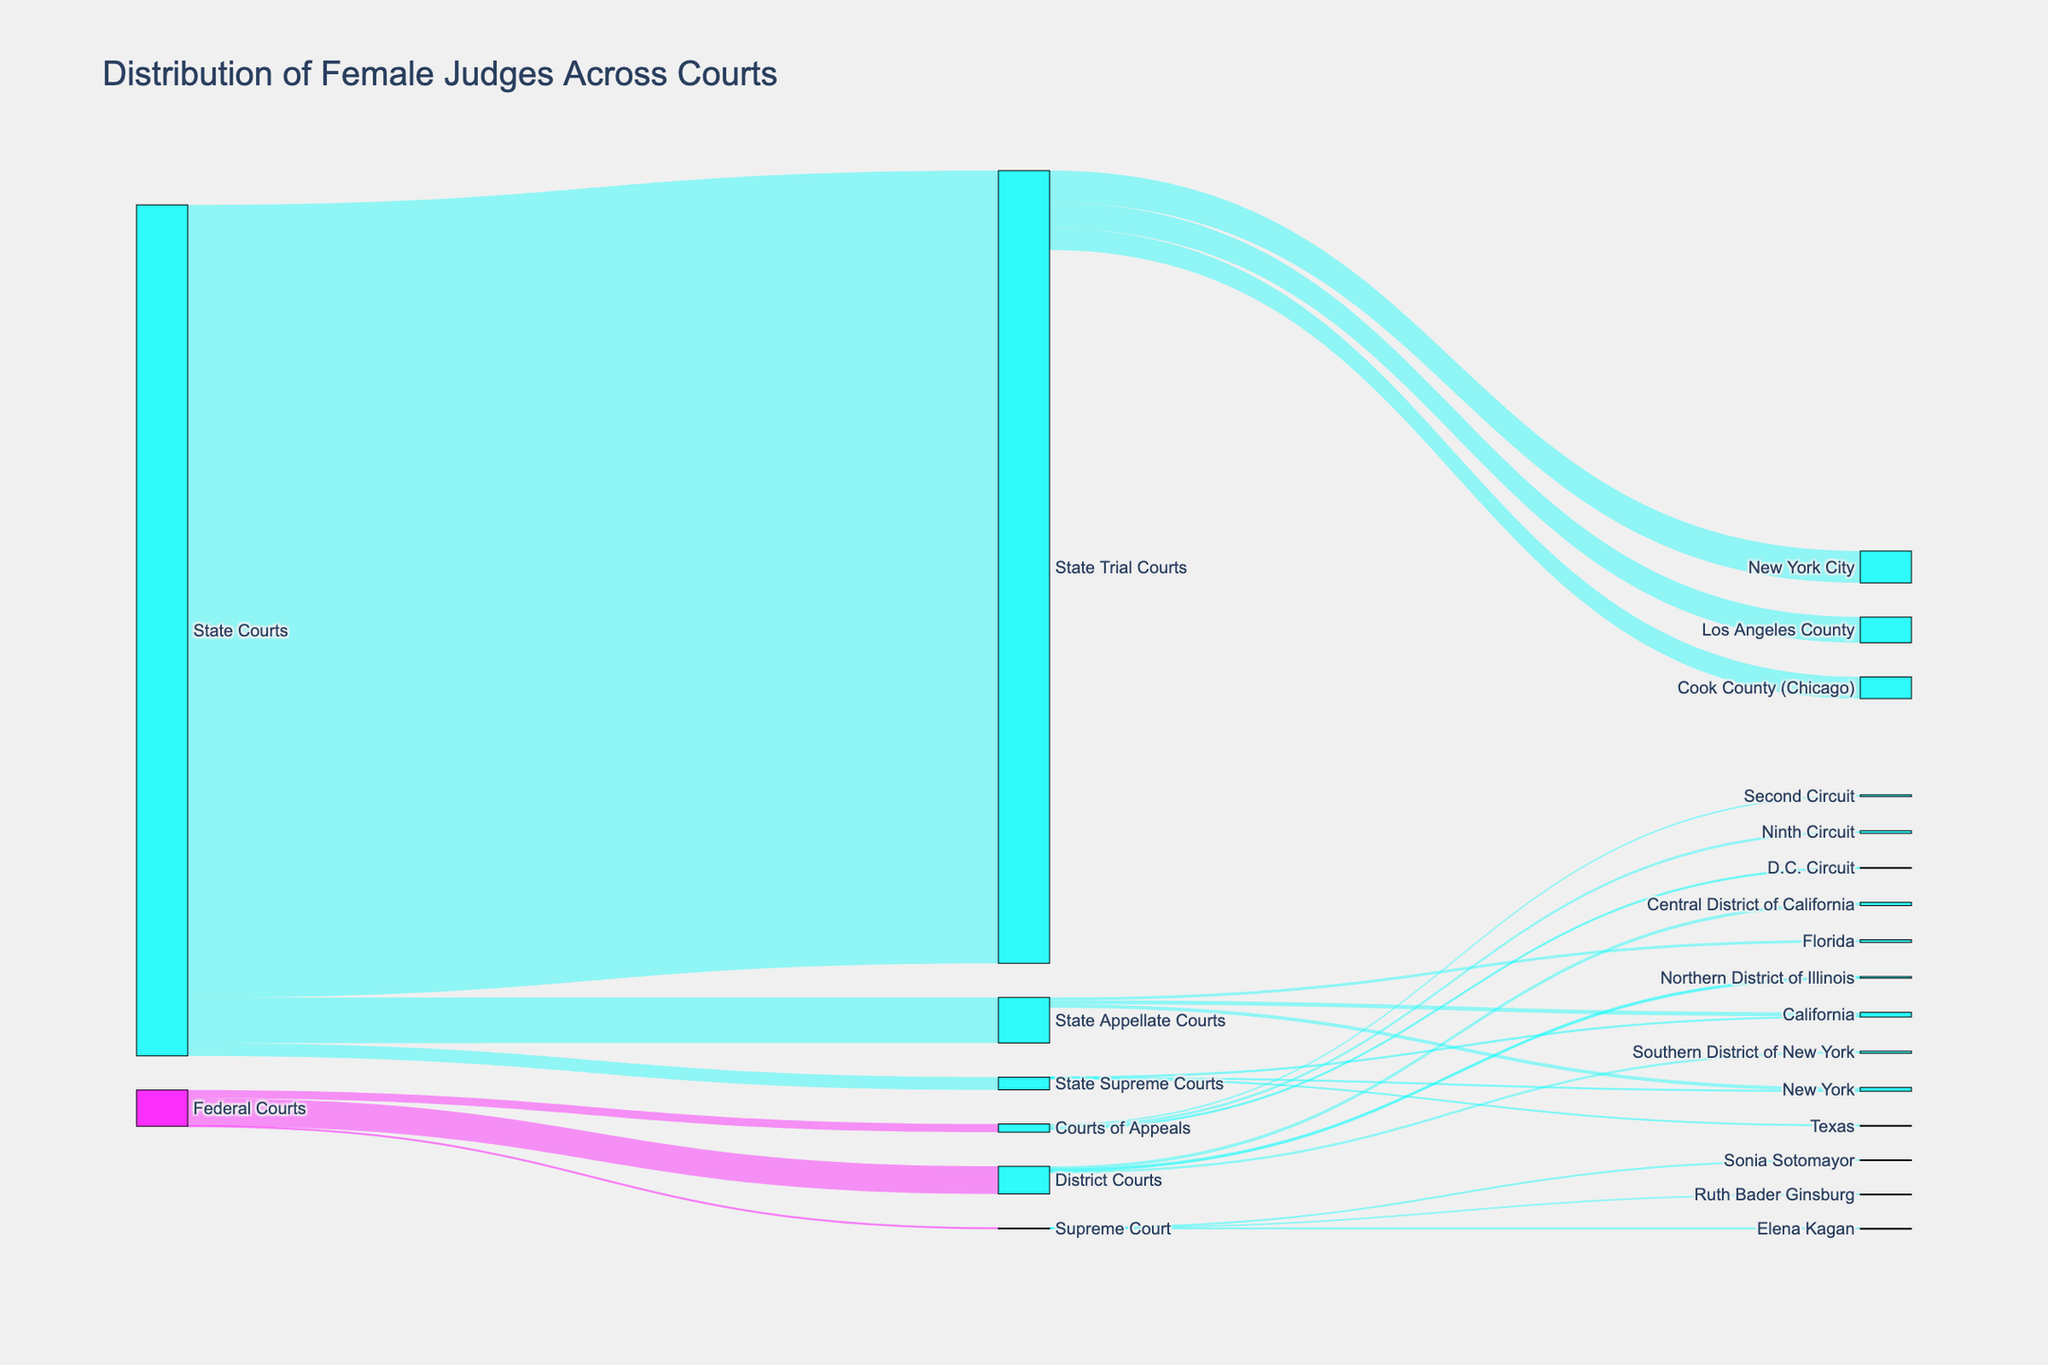What is the title of the figure? The title is usually found at the top of the figure. It gives a brief description of what the figure is about. Here, it states, "Distribution of Female Judges Across Courts."
Answer: Distribution of Female Judges Across Courts How many female judges are shown in State Trial Courts? Look at the node labeled "State Trial Courts" and check the value associated with it, which indicates the number of female judges.
Answer: 5423 Which circuit in the Courts of Appeals has the highest number of female judges? Within the "Courts of Appeals" node, observe the branches leading to the "Second Circuit," "Ninth Circuit," and "D.C. Circuit." The values associated with these targets indicate the number of female judges.
Answer: Ninth Circuit What is the total number of female judges in State Courts? Sum the values of all the categories under "State Courts" (State Supreme Courts, State Appellate Courts, and State Trial Courts). It is 87 + 312 + 5423.
Answer: 5822 How does the number of female judges in the Southern District of New York compare to the Central District of California? Compare the values for "Southern District of New York" and "Central District of California" under the "District Courts" node.
Answer: Southern District of New York: 15, Central District of California: 22 What colors denote Federal and State nodes? Look at the nodes and identify the colors used. Nodes related to "Federal Courts" use one color, while those related to "State Courts" use another.
Answer: Federal: magenta-like (pink), State: cyan-like (blue) How many female judges are there in total in the District Courts? Add up the values for all the districts listed under the "District Courts." These are 15 (Southern District of New York), 22 (Central District of California), and 11 (Northern District of Illinois).
Answer: 48 What proportion of total judges at the Supreme Court are identified as female in this diagram? Identify the number of female judges in the "Supreme Court" node and divide it by the total number of judges (3), then multiply by 100 for the percentage.
Answer: 100% Which state has the highest number of female judges in the State Supreme Courts? Examine the values for different states under the "State Supreme Courts" node; here, "California" has the highest value.
Answer: California Between State Appellate Courts and Courts of Appeals, which has more female judges and by how much? Compare the total values of "State Appellate Courts" and "Courts of Appeals" (312 vs. 56) and calculate the difference.
Answer: State Appellate Courts by 256 